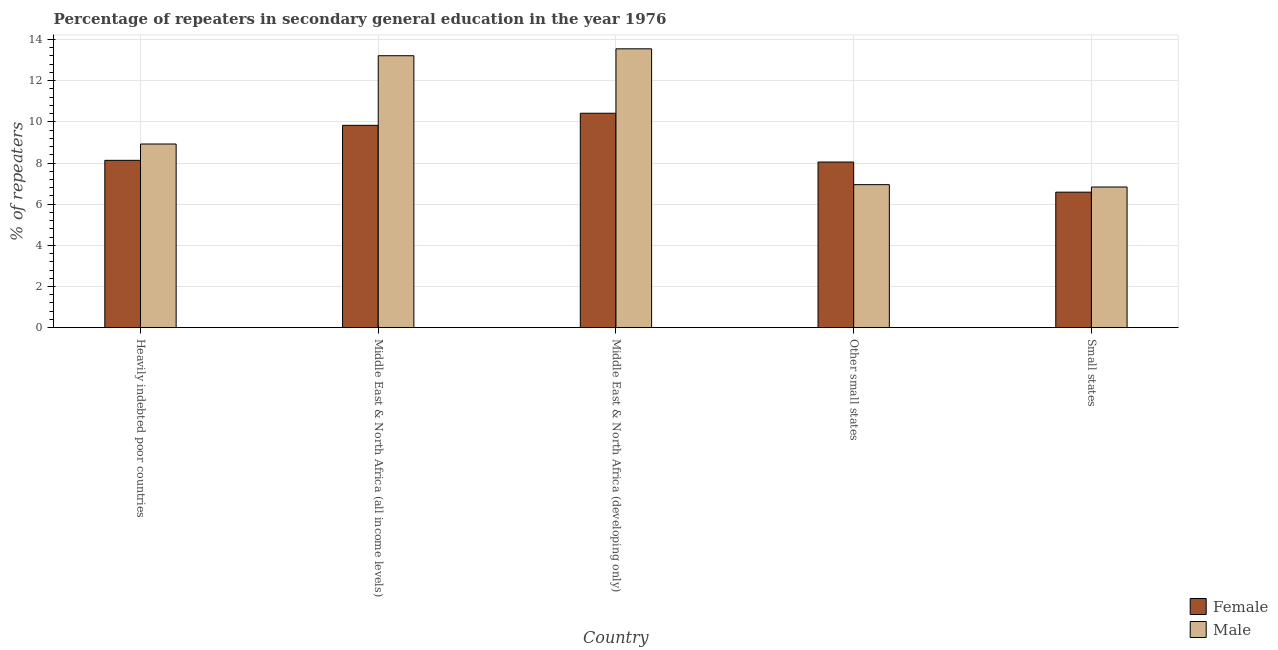How many different coloured bars are there?
Your answer should be very brief. 2. How many groups of bars are there?
Keep it short and to the point. 5. Are the number of bars per tick equal to the number of legend labels?
Keep it short and to the point. Yes. How many bars are there on the 1st tick from the right?
Provide a short and direct response. 2. What is the label of the 4th group of bars from the left?
Provide a succinct answer. Other small states. In how many cases, is the number of bars for a given country not equal to the number of legend labels?
Your answer should be compact. 0. What is the percentage of female repeaters in Middle East & North Africa (all income levels)?
Provide a short and direct response. 9.83. Across all countries, what is the maximum percentage of male repeaters?
Keep it short and to the point. 13.55. Across all countries, what is the minimum percentage of female repeaters?
Make the answer very short. 6.58. In which country was the percentage of male repeaters maximum?
Provide a short and direct response. Middle East & North Africa (developing only). In which country was the percentage of female repeaters minimum?
Ensure brevity in your answer.  Small states. What is the total percentage of female repeaters in the graph?
Offer a terse response. 43.01. What is the difference between the percentage of male repeaters in Heavily indebted poor countries and that in Middle East & North Africa (developing only)?
Offer a terse response. -4.62. What is the difference between the percentage of male repeaters in Heavily indebted poor countries and the percentage of female repeaters in Other small states?
Ensure brevity in your answer.  0.88. What is the average percentage of male repeaters per country?
Ensure brevity in your answer.  9.89. What is the difference between the percentage of male repeaters and percentage of female repeaters in Small states?
Give a very brief answer. 0.25. In how many countries, is the percentage of female repeaters greater than 13.2 %?
Make the answer very short. 0. What is the ratio of the percentage of male repeaters in Middle East & North Africa (developing only) to that in Small states?
Ensure brevity in your answer.  1.98. What is the difference between the highest and the second highest percentage of female repeaters?
Provide a succinct answer. 0.59. What is the difference between the highest and the lowest percentage of female repeaters?
Offer a terse response. 3.83. In how many countries, is the percentage of male repeaters greater than the average percentage of male repeaters taken over all countries?
Your response must be concise. 2. Is the sum of the percentage of male repeaters in Heavily indebted poor countries and Middle East & North Africa (all income levels) greater than the maximum percentage of female repeaters across all countries?
Ensure brevity in your answer.  Yes. What does the 2nd bar from the left in Middle East & North Africa (developing only) represents?
Your answer should be very brief. Male. What does the 1st bar from the right in Middle East & North Africa (developing only) represents?
Make the answer very short. Male. Does the graph contain grids?
Provide a short and direct response. Yes. Where does the legend appear in the graph?
Your response must be concise. Bottom right. How many legend labels are there?
Provide a short and direct response. 2. How are the legend labels stacked?
Provide a short and direct response. Vertical. What is the title of the graph?
Ensure brevity in your answer.  Percentage of repeaters in secondary general education in the year 1976. Does "Private creditors" appear as one of the legend labels in the graph?
Keep it short and to the point. No. What is the label or title of the Y-axis?
Provide a short and direct response. % of repeaters. What is the % of repeaters in Female in Heavily indebted poor countries?
Give a very brief answer. 8.13. What is the % of repeaters in Male in Heavily indebted poor countries?
Provide a succinct answer. 8.92. What is the % of repeaters of Female in Middle East & North Africa (all income levels)?
Provide a succinct answer. 9.83. What is the % of repeaters in Male in Middle East & North Africa (all income levels)?
Ensure brevity in your answer.  13.21. What is the % of repeaters of Female in Middle East & North Africa (developing only)?
Provide a short and direct response. 10.42. What is the % of repeaters in Male in Middle East & North Africa (developing only)?
Offer a very short reply. 13.55. What is the % of repeaters in Female in Other small states?
Give a very brief answer. 8.05. What is the % of repeaters in Male in Other small states?
Your answer should be compact. 6.95. What is the % of repeaters in Female in Small states?
Your response must be concise. 6.58. What is the % of repeaters in Male in Small states?
Your answer should be very brief. 6.83. Across all countries, what is the maximum % of repeaters of Female?
Provide a short and direct response. 10.42. Across all countries, what is the maximum % of repeaters of Male?
Keep it short and to the point. 13.55. Across all countries, what is the minimum % of repeaters of Female?
Your answer should be very brief. 6.58. Across all countries, what is the minimum % of repeaters of Male?
Offer a terse response. 6.83. What is the total % of repeaters of Female in the graph?
Provide a succinct answer. 43.01. What is the total % of repeaters in Male in the graph?
Your answer should be very brief. 49.47. What is the difference between the % of repeaters of Female in Heavily indebted poor countries and that in Middle East & North Africa (all income levels)?
Your answer should be compact. -1.7. What is the difference between the % of repeaters in Male in Heavily indebted poor countries and that in Middle East & North Africa (all income levels)?
Your answer should be compact. -4.29. What is the difference between the % of repeaters in Female in Heavily indebted poor countries and that in Middle East & North Africa (developing only)?
Your answer should be very brief. -2.29. What is the difference between the % of repeaters in Male in Heavily indebted poor countries and that in Middle East & North Africa (developing only)?
Provide a short and direct response. -4.62. What is the difference between the % of repeaters in Female in Heavily indebted poor countries and that in Other small states?
Offer a very short reply. 0.08. What is the difference between the % of repeaters of Male in Heavily indebted poor countries and that in Other small states?
Your answer should be compact. 1.97. What is the difference between the % of repeaters of Female in Heavily indebted poor countries and that in Small states?
Ensure brevity in your answer.  1.55. What is the difference between the % of repeaters of Male in Heavily indebted poor countries and that in Small states?
Provide a succinct answer. 2.09. What is the difference between the % of repeaters in Female in Middle East & North Africa (all income levels) and that in Middle East & North Africa (developing only)?
Offer a terse response. -0.59. What is the difference between the % of repeaters in Male in Middle East & North Africa (all income levels) and that in Middle East & North Africa (developing only)?
Keep it short and to the point. -0.34. What is the difference between the % of repeaters of Female in Middle East & North Africa (all income levels) and that in Other small states?
Provide a short and direct response. 1.78. What is the difference between the % of repeaters in Male in Middle East & North Africa (all income levels) and that in Other small states?
Your answer should be very brief. 6.26. What is the difference between the % of repeaters in Female in Middle East & North Africa (all income levels) and that in Small states?
Keep it short and to the point. 3.25. What is the difference between the % of repeaters in Male in Middle East & North Africa (all income levels) and that in Small states?
Offer a very short reply. 6.38. What is the difference between the % of repeaters in Female in Middle East & North Africa (developing only) and that in Other small states?
Your answer should be very brief. 2.37. What is the difference between the % of repeaters of Male in Middle East & North Africa (developing only) and that in Other small states?
Make the answer very short. 6.6. What is the difference between the % of repeaters in Female in Middle East & North Africa (developing only) and that in Small states?
Make the answer very short. 3.83. What is the difference between the % of repeaters in Male in Middle East & North Africa (developing only) and that in Small states?
Your answer should be compact. 6.71. What is the difference between the % of repeaters in Female in Other small states and that in Small states?
Make the answer very short. 1.46. What is the difference between the % of repeaters of Male in Other small states and that in Small states?
Keep it short and to the point. 0.11. What is the difference between the % of repeaters of Female in Heavily indebted poor countries and the % of repeaters of Male in Middle East & North Africa (all income levels)?
Your answer should be very brief. -5.08. What is the difference between the % of repeaters of Female in Heavily indebted poor countries and the % of repeaters of Male in Middle East & North Africa (developing only)?
Make the answer very short. -5.42. What is the difference between the % of repeaters of Female in Heavily indebted poor countries and the % of repeaters of Male in Other small states?
Provide a short and direct response. 1.18. What is the difference between the % of repeaters in Female in Heavily indebted poor countries and the % of repeaters in Male in Small states?
Ensure brevity in your answer.  1.3. What is the difference between the % of repeaters of Female in Middle East & North Africa (all income levels) and the % of repeaters of Male in Middle East & North Africa (developing only)?
Offer a terse response. -3.72. What is the difference between the % of repeaters of Female in Middle East & North Africa (all income levels) and the % of repeaters of Male in Other small states?
Make the answer very short. 2.88. What is the difference between the % of repeaters in Female in Middle East & North Africa (all income levels) and the % of repeaters in Male in Small states?
Your answer should be very brief. 3. What is the difference between the % of repeaters of Female in Middle East & North Africa (developing only) and the % of repeaters of Male in Other small states?
Your answer should be very brief. 3.47. What is the difference between the % of repeaters in Female in Middle East & North Africa (developing only) and the % of repeaters in Male in Small states?
Your answer should be very brief. 3.58. What is the difference between the % of repeaters of Female in Other small states and the % of repeaters of Male in Small states?
Provide a short and direct response. 1.21. What is the average % of repeaters of Female per country?
Keep it short and to the point. 8.6. What is the average % of repeaters of Male per country?
Provide a succinct answer. 9.89. What is the difference between the % of repeaters in Female and % of repeaters in Male in Heavily indebted poor countries?
Provide a succinct answer. -0.79. What is the difference between the % of repeaters in Female and % of repeaters in Male in Middle East & North Africa (all income levels)?
Offer a very short reply. -3.38. What is the difference between the % of repeaters in Female and % of repeaters in Male in Middle East & North Africa (developing only)?
Offer a very short reply. -3.13. What is the difference between the % of repeaters of Female and % of repeaters of Male in Other small states?
Keep it short and to the point. 1.1. What is the difference between the % of repeaters in Female and % of repeaters in Male in Small states?
Your response must be concise. -0.25. What is the ratio of the % of repeaters in Female in Heavily indebted poor countries to that in Middle East & North Africa (all income levels)?
Give a very brief answer. 0.83. What is the ratio of the % of repeaters in Male in Heavily indebted poor countries to that in Middle East & North Africa (all income levels)?
Ensure brevity in your answer.  0.68. What is the ratio of the % of repeaters in Female in Heavily indebted poor countries to that in Middle East & North Africa (developing only)?
Keep it short and to the point. 0.78. What is the ratio of the % of repeaters of Male in Heavily indebted poor countries to that in Middle East & North Africa (developing only)?
Offer a very short reply. 0.66. What is the ratio of the % of repeaters of Female in Heavily indebted poor countries to that in Other small states?
Give a very brief answer. 1.01. What is the ratio of the % of repeaters in Male in Heavily indebted poor countries to that in Other small states?
Your answer should be very brief. 1.28. What is the ratio of the % of repeaters in Female in Heavily indebted poor countries to that in Small states?
Give a very brief answer. 1.24. What is the ratio of the % of repeaters in Male in Heavily indebted poor countries to that in Small states?
Your response must be concise. 1.31. What is the ratio of the % of repeaters of Female in Middle East & North Africa (all income levels) to that in Middle East & North Africa (developing only)?
Your answer should be very brief. 0.94. What is the ratio of the % of repeaters in Male in Middle East & North Africa (all income levels) to that in Middle East & North Africa (developing only)?
Your response must be concise. 0.98. What is the ratio of the % of repeaters in Female in Middle East & North Africa (all income levels) to that in Other small states?
Provide a short and direct response. 1.22. What is the ratio of the % of repeaters of Male in Middle East & North Africa (all income levels) to that in Other small states?
Offer a terse response. 1.9. What is the ratio of the % of repeaters of Female in Middle East & North Africa (all income levels) to that in Small states?
Provide a succinct answer. 1.49. What is the ratio of the % of repeaters of Male in Middle East & North Africa (all income levels) to that in Small states?
Your response must be concise. 1.93. What is the ratio of the % of repeaters in Female in Middle East & North Africa (developing only) to that in Other small states?
Offer a terse response. 1.29. What is the ratio of the % of repeaters in Male in Middle East & North Africa (developing only) to that in Other small states?
Provide a short and direct response. 1.95. What is the ratio of the % of repeaters in Female in Middle East & North Africa (developing only) to that in Small states?
Keep it short and to the point. 1.58. What is the ratio of the % of repeaters in Male in Middle East & North Africa (developing only) to that in Small states?
Your response must be concise. 1.98. What is the ratio of the % of repeaters in Female in Other small states to that in Small states?
Keep it short and to the point. 1.22. What is the ratio of the % of repeaters of Male in Other small states to that in Small states?
Your answer should be compact. 1.02. What is the difference between the highest and the second highest % of repeaters in Female?
Offer a very short reply. 0.59. What is the difference between the highest and the second highest % of repeaters of Male?
Provide a short and direct response. 0.34. What is the difference between the highest and the lowest % of repeaters of Female?
Offer a very short reply. 3.83. What is the difference between the highest and the lowest % of repeaters in Male?
Give a very brief answer. 6.71. 